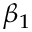Convert formula to latex. <formula><loc_0><loc_0><loc_500><loc_500>\beta _ { 1 }</formula> 